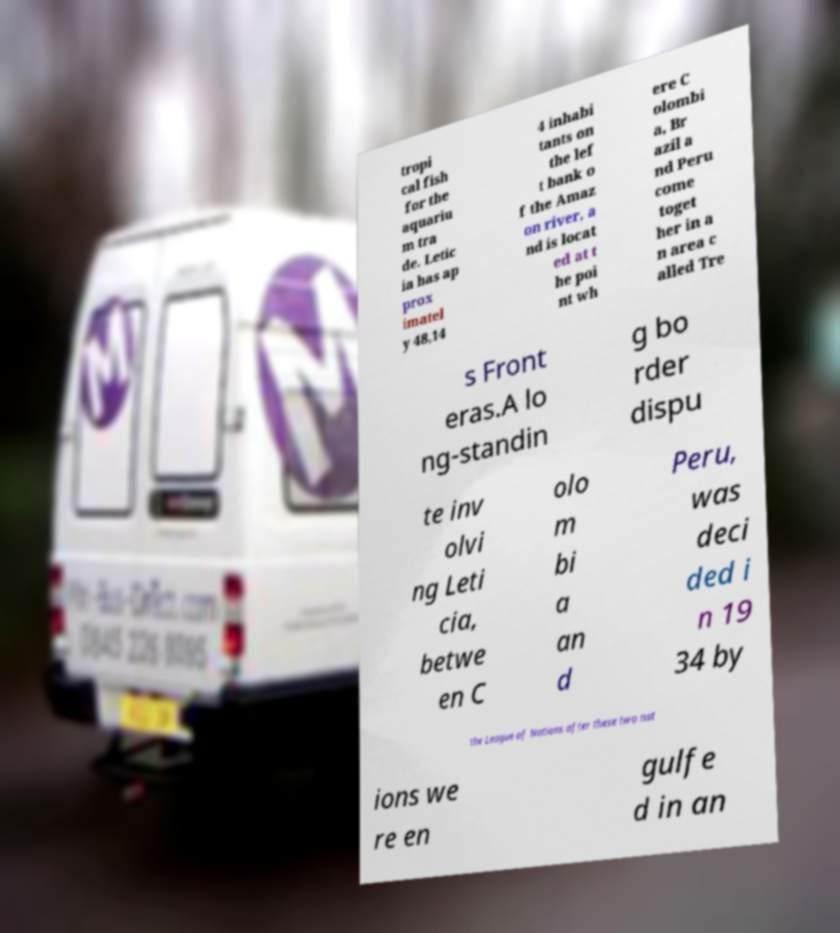Please identify and transcribe the text found in this image. tropi cal fish for the aquariu m tra de. Letic ia has ap prox imatel y 48,14 4 inhabi tants on the lef t bank o f the Amaz on river, a nd is locat ed at t he poi nt wh ere C olombi a, Br azil a nd Peru come toget her in a n area c alled Tre s Front eras.A lo ng-standin g bo rder dispu te inv olvi ng Leti cia, betwe en C olo m bi a an d Peru, was deci ded i n 19 34 by the League of Nations after these two nat ions we re en gulfe d in an 